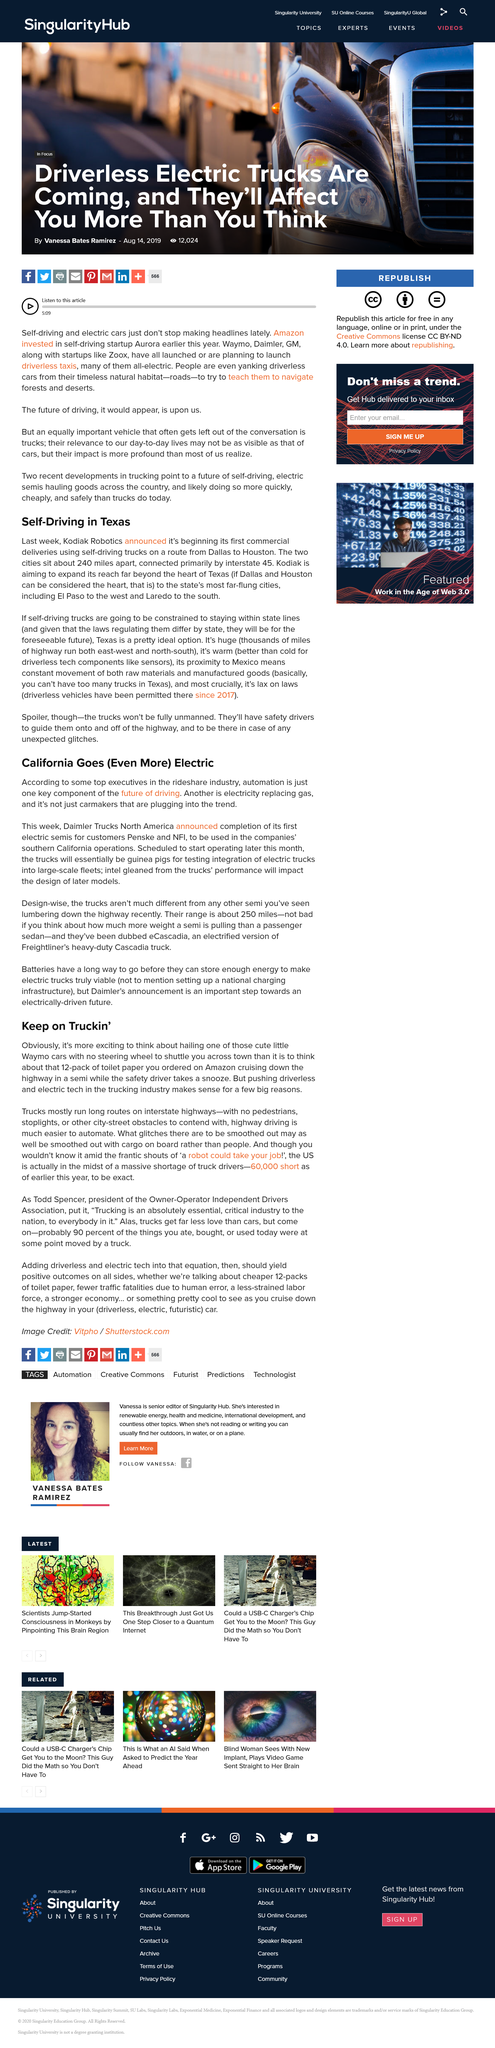Indicate a few pertinent items in this graphic. Kodiak Robotics is commencing the launch of its self-driving truck service in Texas. The title of the article suggests that California is moving towards a greater use of electricity. Driverless technology in the trucking industry is justified due to the acute shortage of truck drivers, resulting in a significant labor shortage. There is a shortage of approximately 60,000 truck drivers in the United States. Dallas is approximately 240 miles away from Houston, and this distance is the distance between the two cities. 